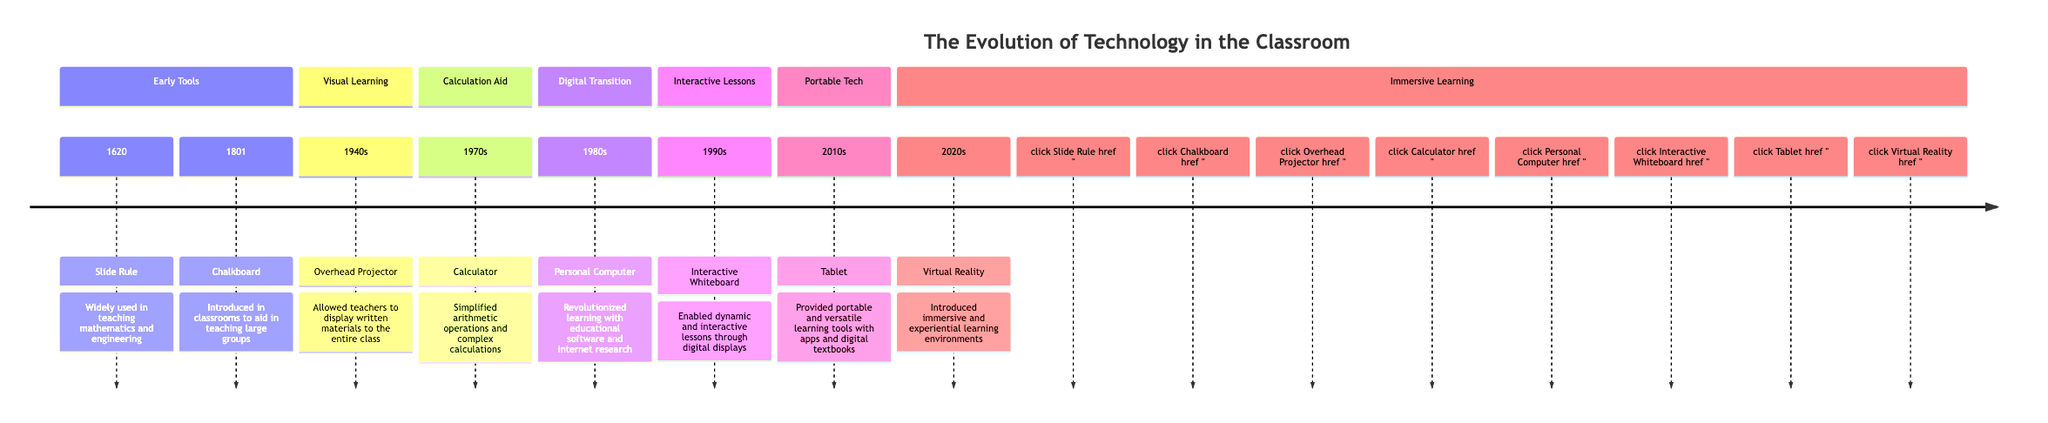What was introduced in 1620? According to the timeline, the Slide Rule was the key innovation in 1620.
Answer: Slide Rule Which tool was used for teaching large groups? The Chalkboard, introduced in 1801, was specifically mentioned as a tool for teaching large groups.
Answer: Chalkboard What decade did the Calculator appear? The timeline shows that the Calculator became a significant educational tool in the 1970s.
Answer: 1970s Which innovation revolutionized learning in the 1980s? The Personal Computer is identified in the timeline as the innovation that revolutionized learning in the 1980s.
Answer: Personal Computer How many innovations are listed in the Visual Learning section? The Visual Learning section contains one innovation, which is the Overhead Projector in the 1940s.
Answer: 1 What technology was introduced in the 1990s for interactive lessons? The Interactive Whiteboard was introduced in the 1990s to enable dynamic and interactive lessons.
Answer: Interactive Whiteboard What is the most recent educational tool mentioned? The timeline indicates that Virtual Reality is the latest educational tool mentioned, introduced in the 2020s.
Answer: Virtual Reality Which innovation provided portable learning tools in the 2010s? The Tablet is noted as the portable learning tool introduced in the 2010s.
Answer: Tablet What is the relationship between the introduction of the Personal Computer and educational software? The Personal Computer revolutionized learning with educational software, indicating a direct relationship where the emergence of the PC facilitated the development and use of educational software.
Answer: Revolutionized learning with educational software 